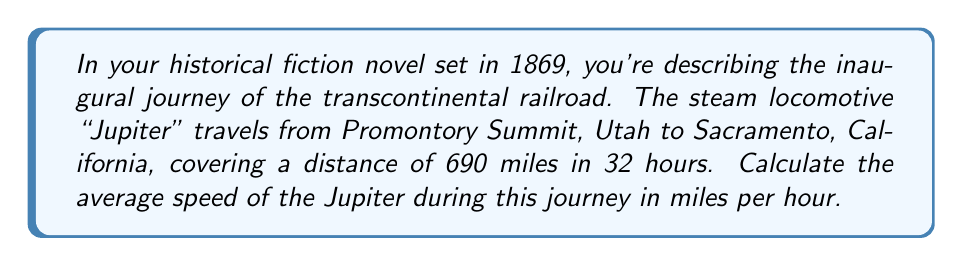Show me your answer to this math problem. To solve this problem, we need to use the formula for average speed:

$$\text{Average Speed} = \frac{\text{Total Distance}}{\text{Total Time}}$$

Given:
- Total Distance = 690 miles
- Total Time = 32 hours

Let's substitute these values into the formula:

$$\text{Average Speed} = \frac{690 \text{ miles}}{32 \text{ hours}}$$

Now, we can perform the division:

$$\text{Average Speed} = 21.5625 \text{ miles per hour}$$

Rounding to two decimal places for a more practical representation:

$$\text{Average Speed} \approx 21.56 \text{ miles per hour}$$

This calculation gives us the average speed of the Jupiter steam locomotive over the entire journey from Promontory Summit to Sacramento.
Answer: $21.56 \text{ miles per hour}$ 